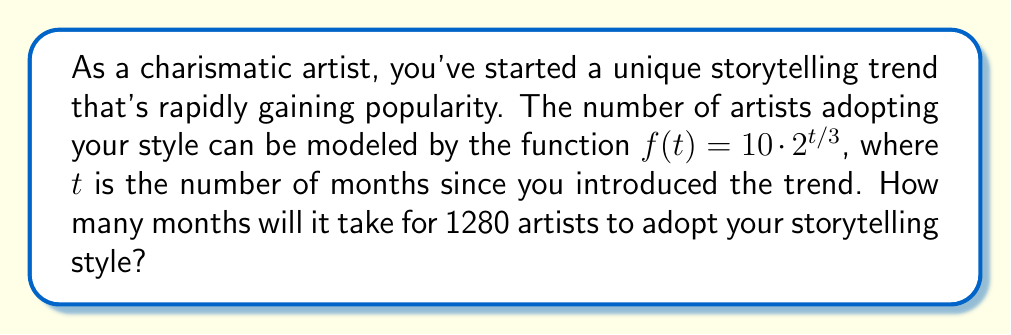Can you solve this math problem? Let's approach this step-by-step:

1) We're given the function $f(t) = 10 \cdot 2^{t/3}$, where $f(t)$ represents the number of artists and $t$ represents the number of months.

2) We need to find $t$ when $f(t) = 1280$. So, let's set up the equation:

   $1280 = 10 \cdot 2^{t/3}$

3) First, divide both sides by 10:

   $128 = 2^{t/3}$

4) Now, we can take the logarithm (base 2) of both sides:

   $\log_2(128) = \log_2(2^{t/3})$

5) Using the logarithm property $\log_a(a^x) = x$, we get:

   $\log_2(128) = t/3$

6) We know that $2^7 = 128$, so $\log_2(128) = 7$. Therefore:

   $7 = t/3$

7) Multiply both sides by 3:

   $21 = t$

Thus, it will take 21 months for 1280 artists to adopt your storytelling style.
Answer: 21 months 